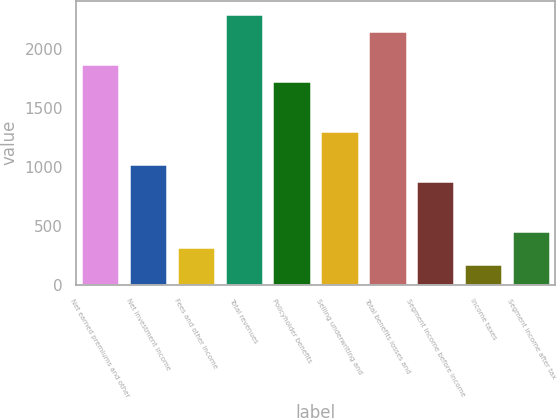<chart> <loc_0><loc_0><loc_500><loc_500><bar_chart><fcel>Net earned premiums and other<fcel>Net investment income<fcel>Fees and other income<fcel>Total revenues<fcel>Policyholder benefits<fcel>Selling underwriting and<fcel>Total benefits losses and<fcel>Segment income before income<fcel>Income taxes<fcel>Segment income after tax<nl><fcel>1875.07<fcel>1024.93<fcel>316.48<fcel>2300.14<fcel>1733.38<fcel>1308.31<fcel>2158.45<fcel>883.24<fcel>174.79<fcel>458.17<nl></chart> 